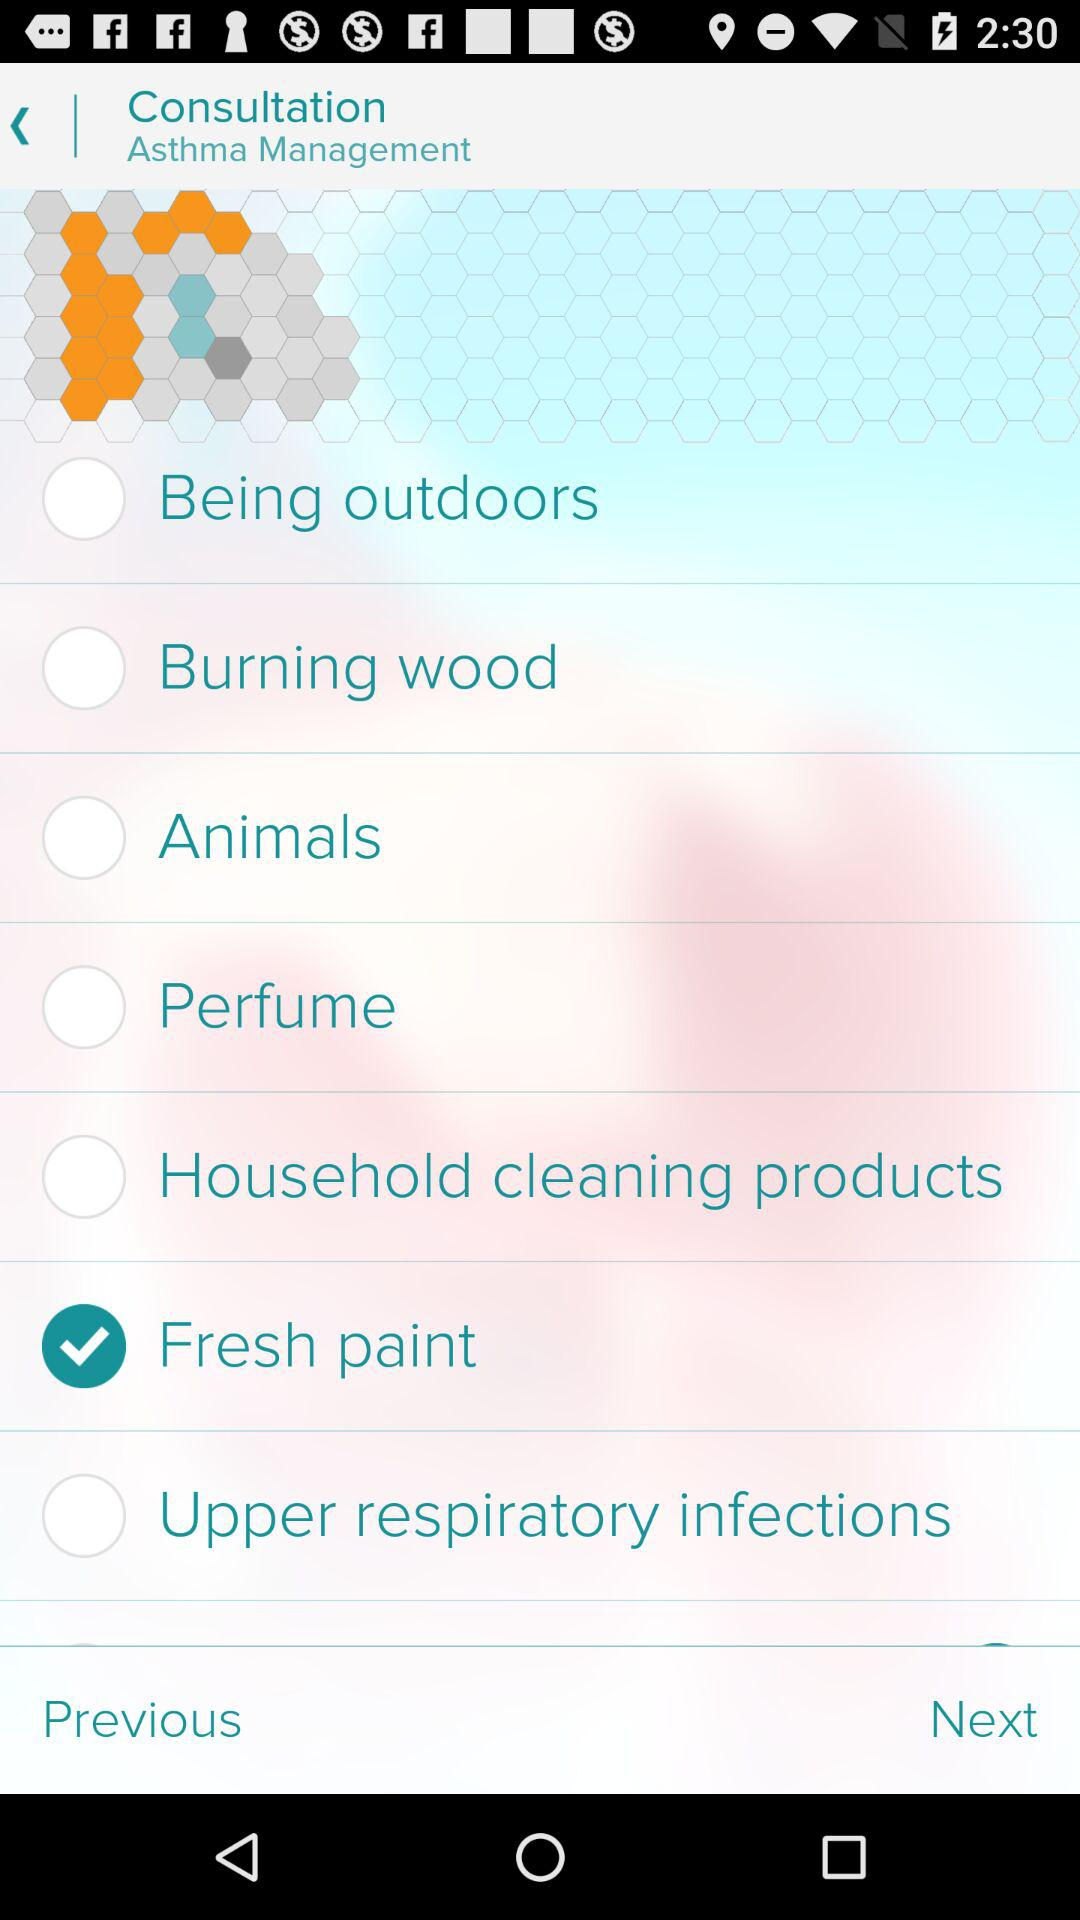What is the status of "Animals"? The status is "off". 